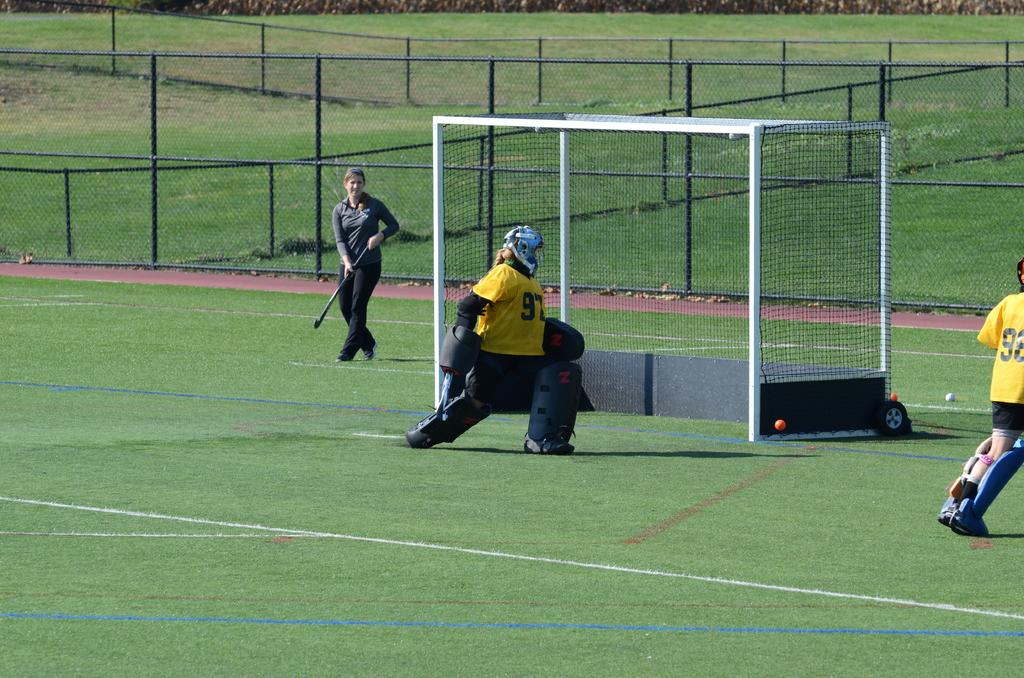<image>
Offer a succinct explanation of the picture presented. An athlete playing the position of goalie is wearing jersey number 97. 